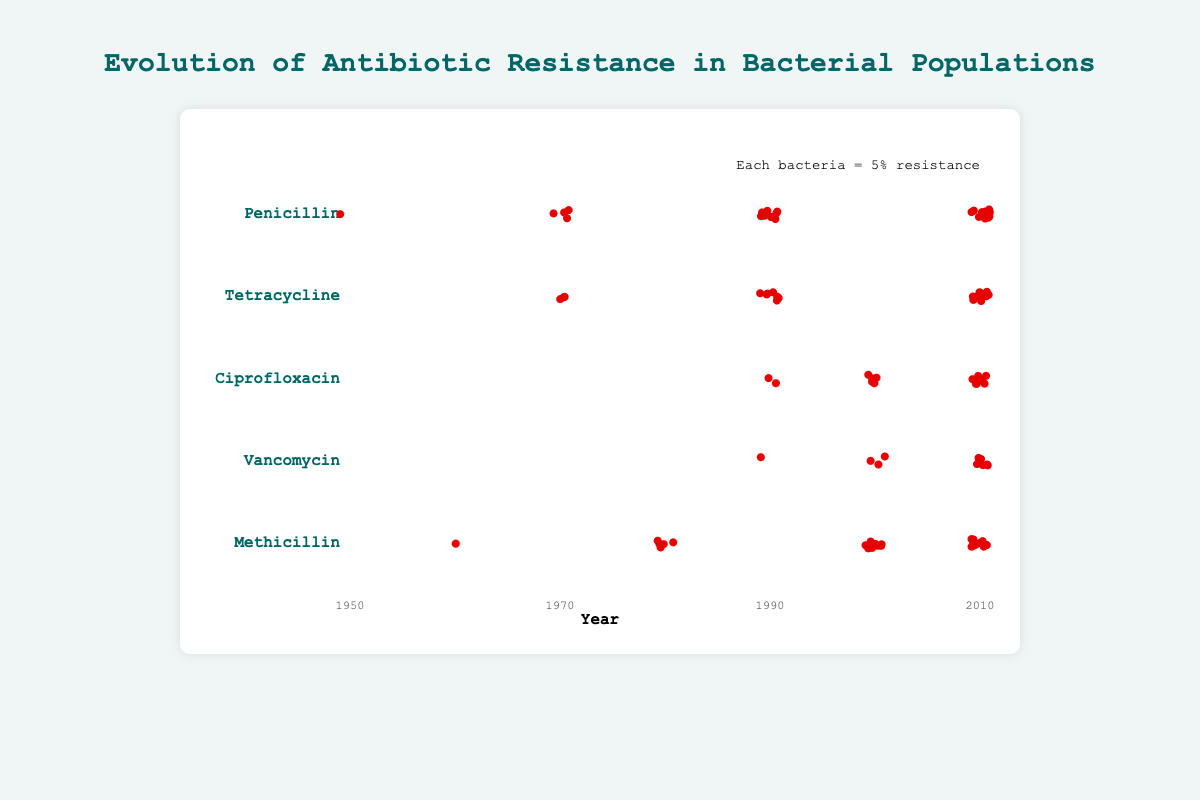What's the title of the figure? The title of the figure is placed at the top center and reads "Evolution of Antibiotic Resistance in Bacterial Populations".
Answer: Evolution of Antibiotic Resistance in Bacterial Populations Which antibiotic shows the highest resistance rate in 2010? By looking at the resistance rates for each antibiotic in 2010, Penicillin shows the highest resistance rate at 70%.
Answer: Penicillin How many types of antibiotics are shown in the figure? The figure shows the labels for each type of antibiotic on the y-axis. Counting these labels, we see there are five antibiotics: Penicillin, Tetracycline, Ciprofloxacin, Vancomycin, and Methicillin.
Answer: 5 What is the resistance rate for Vancomycin in 2000? The resistance rate for Vancomycin in the year 2000 is listed as 15%.
Answer: 15% Which two antibiotics had the same resistance rate in 1990 and what is that rate? By examining the resistance rates for 1990, we see both Penicillin and Tetracycline had a resistance rate of 45% and 35% respectively.
Answer: None Between 1950 and 2010, which antibiotic had the greatest increase in resistance rate? Subtract the resistance rates for each antibiotic in 1950 from their 2010 rates: Penicillin (65% increase), Tetracycline (53% increase), Ciprofloxacin (not applicable as data starts from 1990), Vancomycin (29% increase), and Methicillin (62% increase). Penicillin shows the greatest increase with 65%.
Answer: Penicillin By how many percentage points did the resistance rate of Methicillin increase from 1980 to 2000? The resistance rate of Methicillin in 1980 was 25% and in 2000 it was 50%, showing an increase of 50 - 25 = 25 percentage points.
Answer: 25 Which antibiotic had the lowest resistance rate in the earliest recorded year? Vancomycin had the lowest resistance rate in the earliest recorded year, which was 1980 with a resistance rate of 1%.
Answer: Vancomycin In what years is resistance data missing for Ciprofloxacin? Looking at the years listed for Ciprofloxacin (1990, 2000, 2010), the resistance data for this antibiotic is missing for the years before 1990, such as 1950, 1970, and 1980.
Answer: 1950, 1970, 1980 What's the average resistance rate of Tetracycline across all years shown? The resistance rates for Tetracycline across the years 1950, 1970, 1990, 2010 are 2%, 15%, 35%, 55%. Adding these rates: 2 + 15 + 35 + 55 = 107 and dividing by 4 gives an average of 107/4 = 26.75%.
Answer: 26.75% 